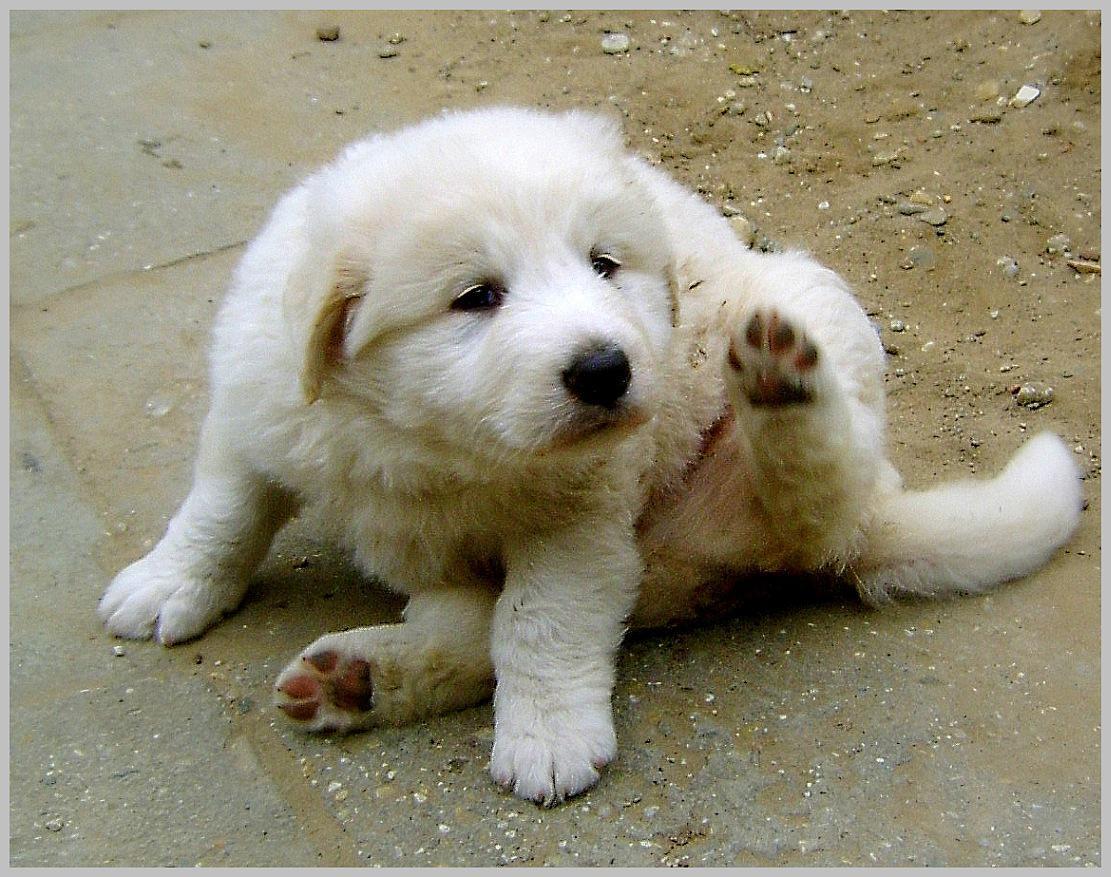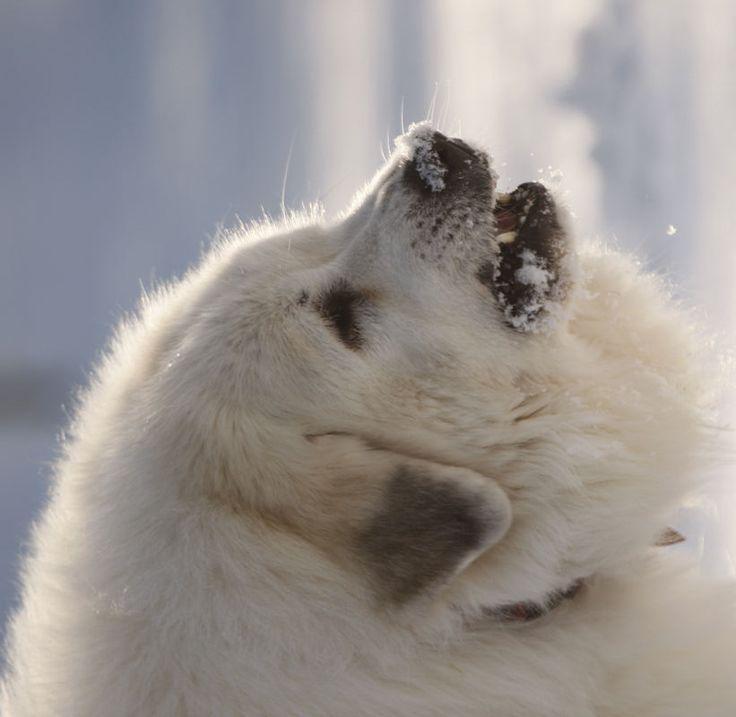The first image is the image on the left, the second image is the image on the right. Evaluate the accuracy of this statement regarding the images: "The left photo is of a puppy.". Is it true? Answer yes or no. Yes. 